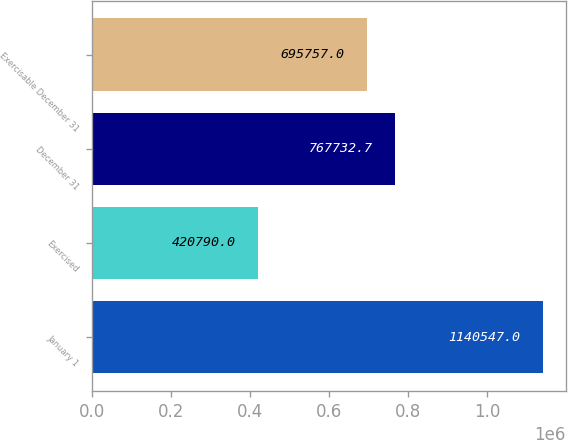Convert chart. <chart><loc_0><loc_0><loc_500><loc_500><bar_chart><fcel>January 1<fcel>Exercised<fcel>December 31<fcel>Exercisable December 31<nl><fcel>1.14055e+06<fcel>420790<fcel>767733<fcel>695757<nl></chart> 